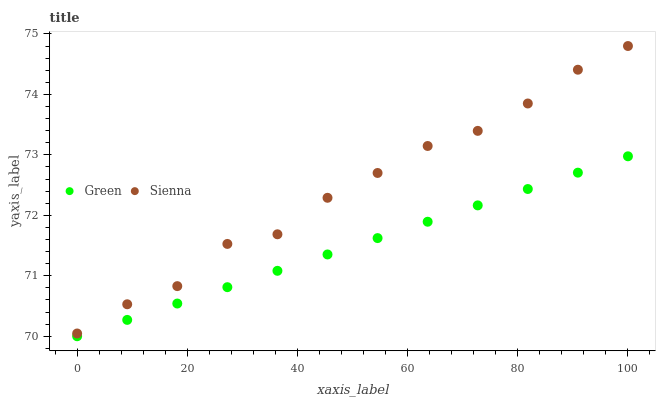Does Green have the minimum area under the curve?
Answer yes or no. Yes. Does Sienna have the maximum area under the curve?
Answer yes or no. Yes. Does Green have the maximum area under the curve?
Answer yes or no. No. Is Green the smoothest?
Answer yes or no. Yes. Is Sienna the roughest?
Answer yes or no. Yes. Is Green the roughest?
Answer yes or no. No. Does Green have the lowest value?
Answer yes or no. Yes. Does Sienna have the highest value?
Answer yes or no. Yes. Does Green have the highest value?
Answer yes or no. No. Is Green less than Sienna?
Answer yes or no. Yes. Is Sienna greater than Green?
Answer yes or no. Yes. Does Green intersect Sienna?
Answer yes or no. No. 